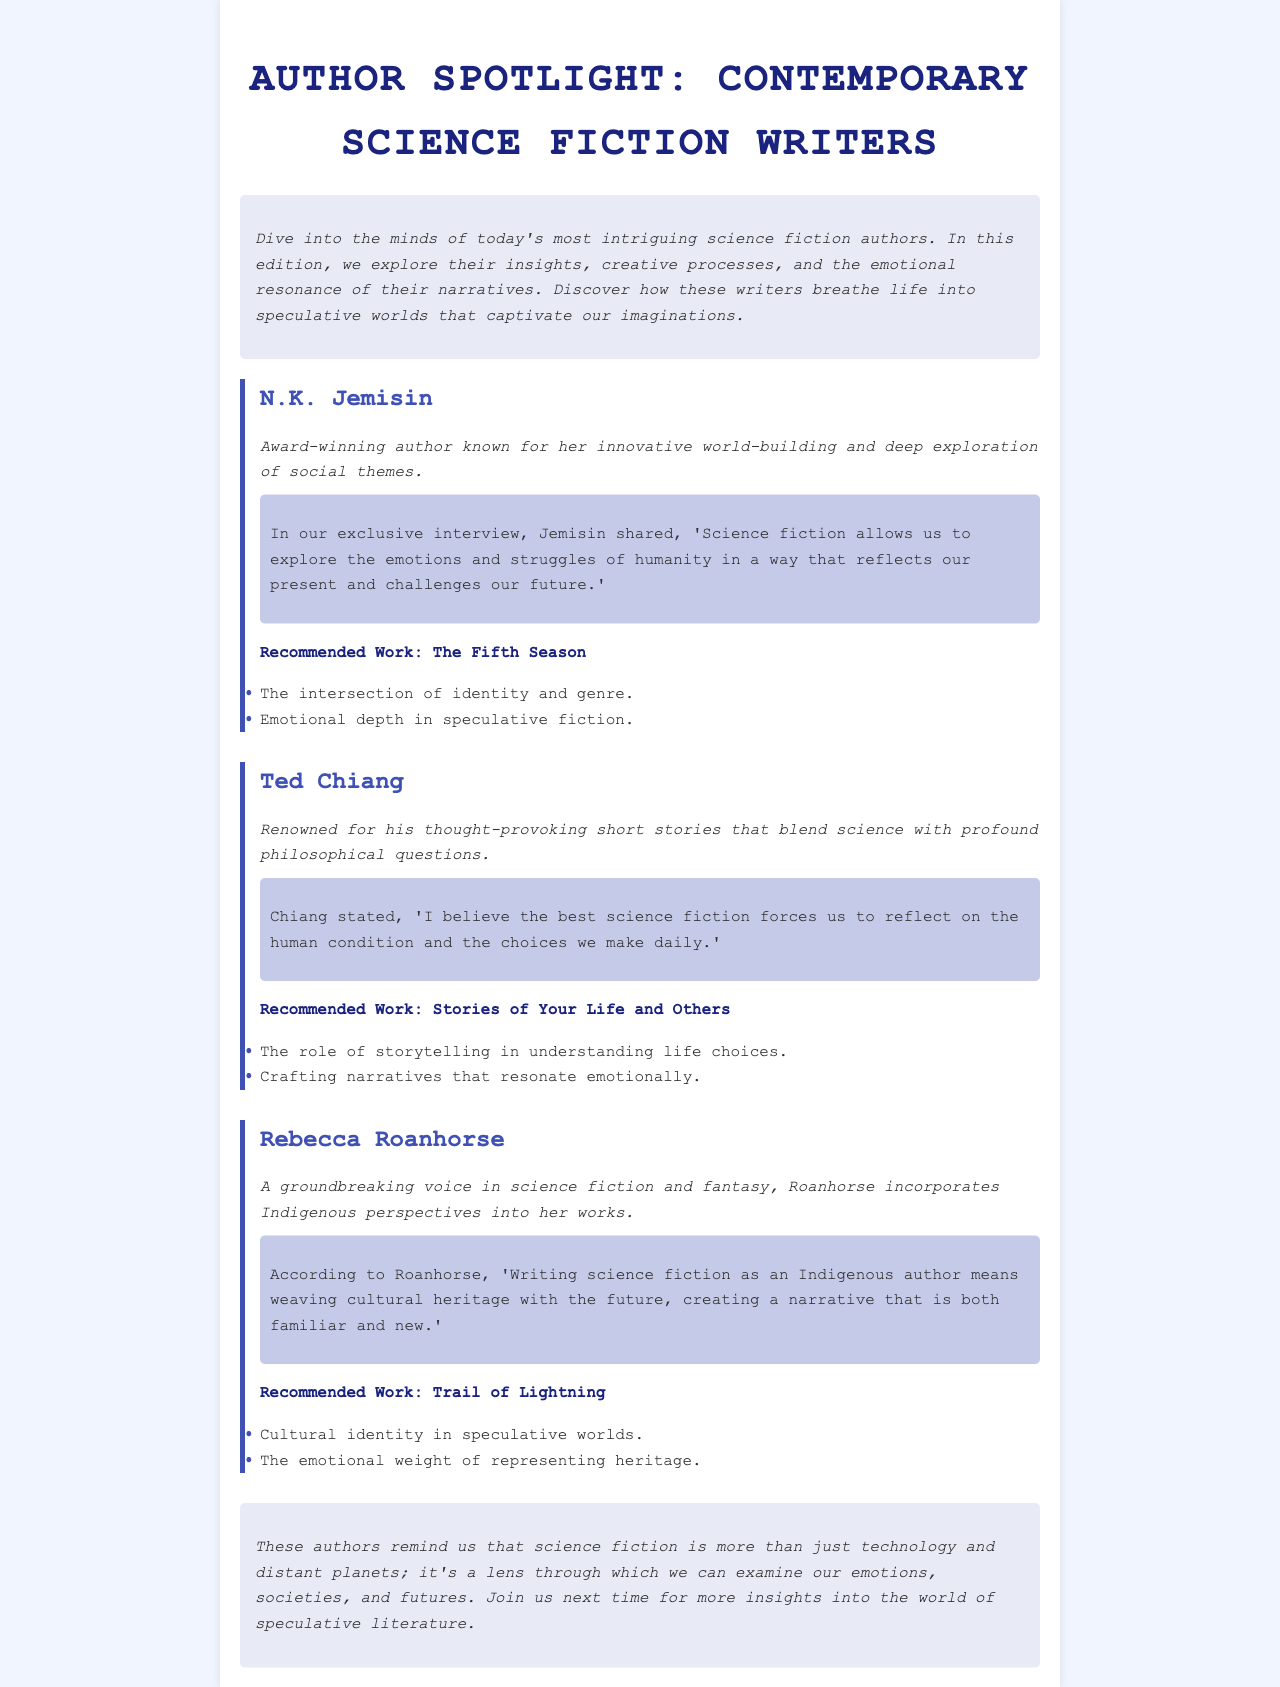What is the title of the newsletter? The title is mentioned at the top of the document.
Answer: Author Spotlight: Contemporary Science Fiction Writers Who is the author known for "The Fifth Season"? The document lists authors along with their recommended works.
Answer: N.K. Jemisin What notable work is suggested for Ted Chiang? The recommended work is provided in his section.
Answer: Stories of Your Life and Others What theme does Rebecca Roanhorse address in her writing? The document specifies themes related to her works.
Answer: Cultural identity in speculative worlds What is the main focus of the interviews featured? The introductory section elaborates on the purpose of the interviews.
Answer: Insights, creative processes, and emotional resonance 